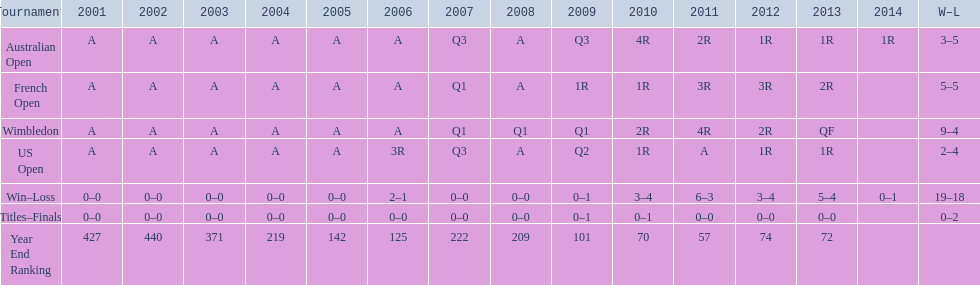Help me parse the entirety of this table. {'header': ['Tournament', '2001', '2002', '2003', '2004', '2005', '2006', '2007', '2008', '2009', '2010', '2011', '2012', '2013', '2014', 'W–L'], 'rows': [['Australian Open', 'A', 'A', 'A', 'A', 'A', 'A', 'Q3', 'A', 'Q3', '4R', '2R', '1R', '1R', '1R', '3–5'], ['French Open', 'A', 'A', 'A', 'A', 'A', 'A', 'Q1', 'A', '1R', '1R', '3R', '3R', '2R', '', '5–5'], ['Wimbledon', 'A', 'A', 'A', 'A', 'A', 'A', 'Q1', 'Q1', 'Q1', '2R', '4R', '2R', 'QF', '', '9–4'], ['US Open', 'A', 'A', 'A', 'A', 'A', '3R', 'Q3', 'A', 'Q2', '1R', 'A', '1R', '1R', '', '2–4'], ['Win–Loss', '0–0', '0–0', '0–0', '0–0', '0–0', '2–1', '0–0', '0–0', '0–1', '3–4', '6–3', '3–4', '5–4', '0–1', '19–18'], ['Titles–Finals', '0–0', '0–0', '0–0', '0–0', '0–0', '0–0', '0–0', '0–0', '0–1', '0–1', '0–0', '0–0', '0–0', '', '0–2'], ['Year End Ranking', '427', '440', '371', '219', '142', '125', '222', '209', '101', '70', '57', '74', '72', '', '']]} In what year was the top year-end ranking accomplished? 2011. 